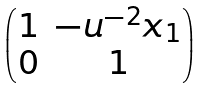<formula> <loc_0><loc_0><loc_500><loc_500>\begin{pmatrix} 1 & - u ^ { - 2 } x _ { 1 } \\ 0 & 1 \end{pmatrix}</formula> 